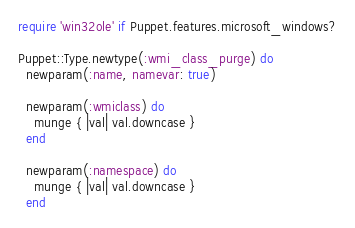<code> <loc_0><loc_0><loc_500><loc_500><_Ruby_>require 'win32ole' if Puppet.features.microsoft_windows?

Puppet::Type.newtype(:wmi_class_purge) do
  newparam(:name, namevar: true)

  newparam(:wmiclass) do
    munge { |val| val.downcase }
  end

  newparam(:namespace) do
    munge { |val| val.downcase }
  end
</code> 